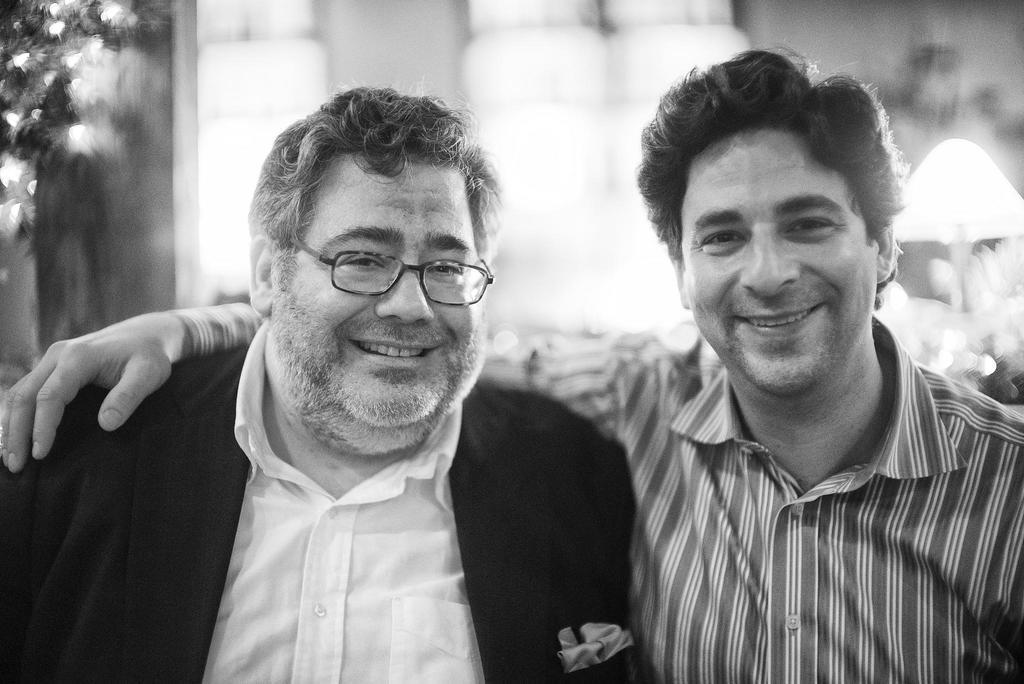What is the color scheme of the image? The image is black and white. How many people are in the foreground of the image? There are two persons in the foreground of the image. What is one person wearing? One person is wearing a suit. Can you describe the background of the image? The background of the image is blurred. What type of fowl can be seen in the park in the image? There is no fowl or park present in the image; it is a black and white image with two persons in the foreground and a blurred background. 